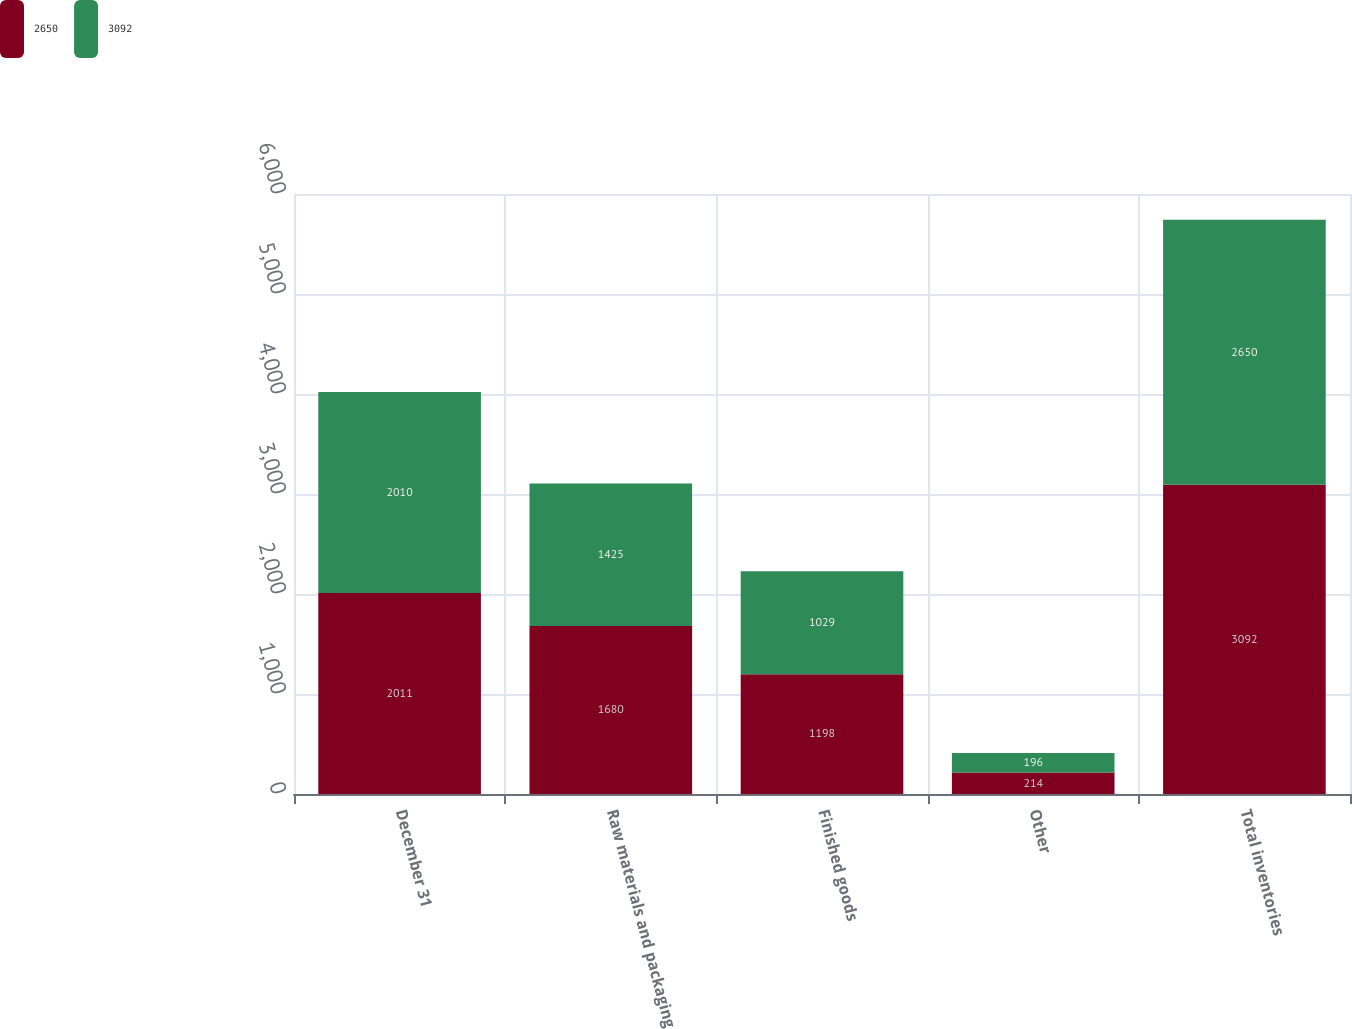<chart> <loc_0><loc_0><loc_500><loc_500><stacked_bar_chart><ecel><fcel>December 31<fcel>Raw materials and packaging<fcel>Finished goods<fcel>Other<fcel>Total inventories<nl><fcel>2650<fcel>2011<fcel>1680<fcel>1198<fcel>214<fcel>3092<nl><fcel>3092<fcel>2010<fcel>1425<fcel>1029<fcel>196<fcel>2650<nl></chart> 